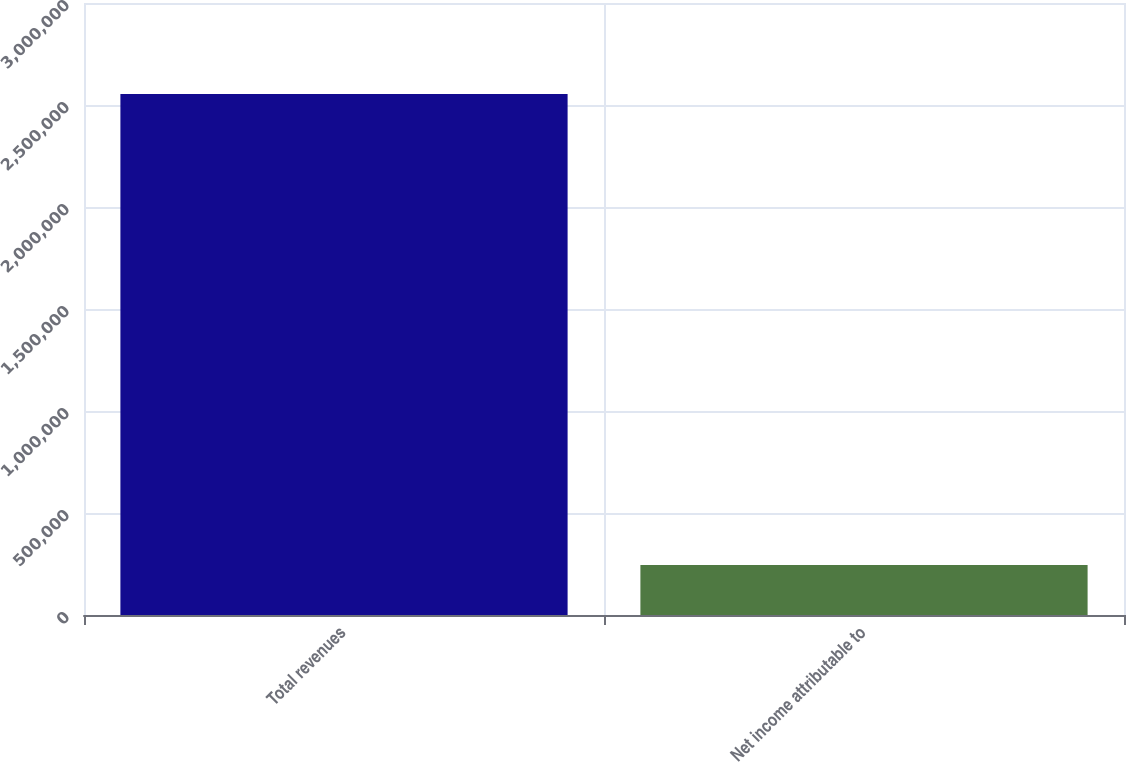<chart> <loc_0><loc_0><loc_500><loc_500><bar_chart><fcel>Total revenues<fcel>Net income attributable to<nl><fcel>2.55424e+06<fcel>245286<nl></chart> 